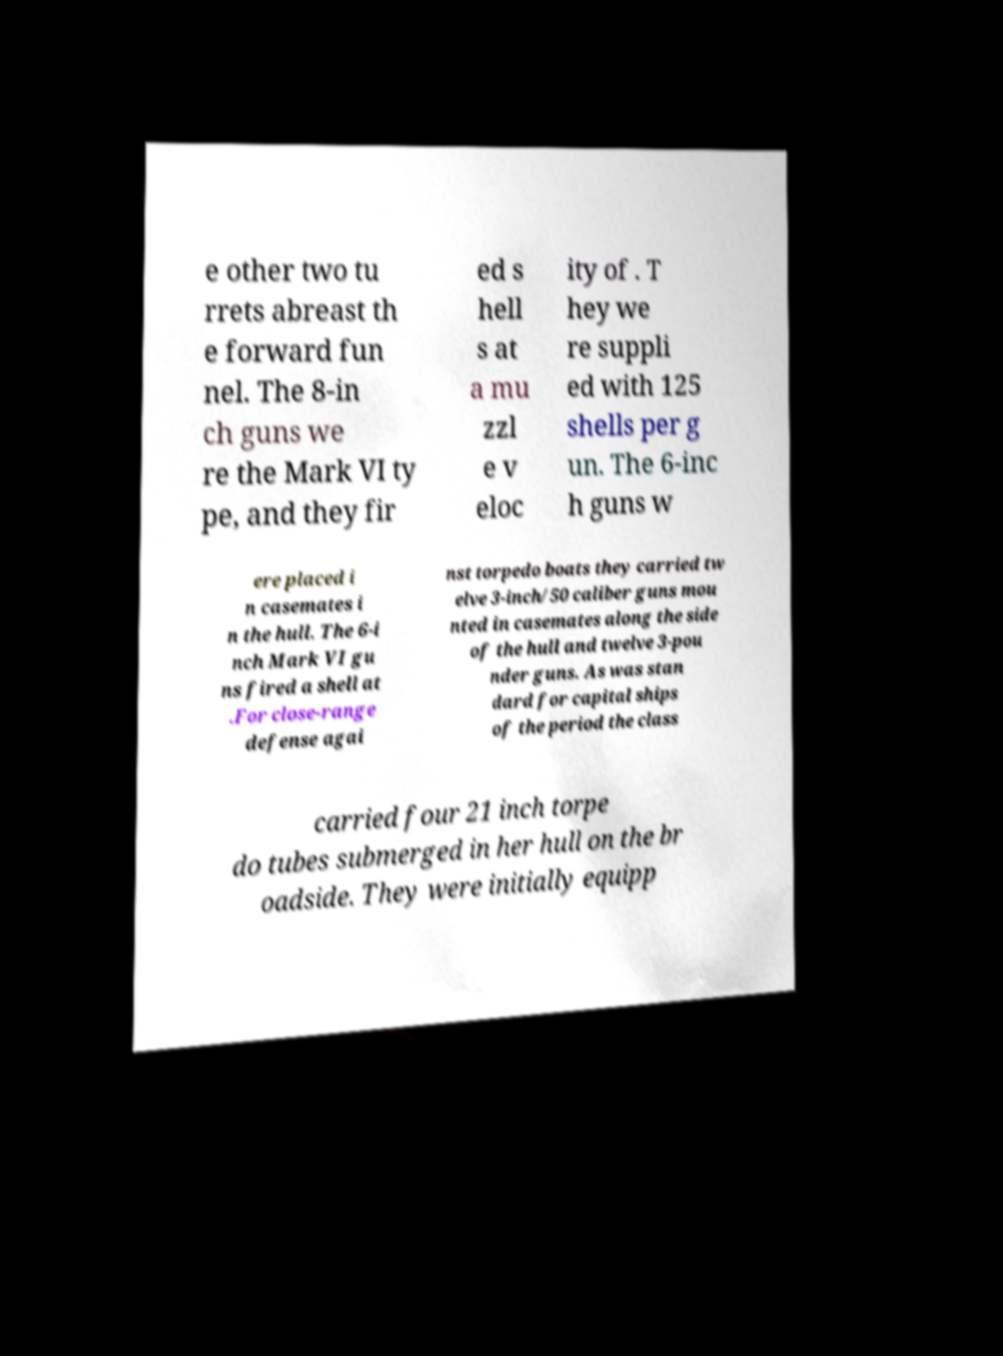Please read and relay the text visible in this image. What does it say? e other two tu rrets abreast th e forward fun nel. The 8-in ch guns we re the Mark VI ty pe, and they fir ed s hell s at a mu zzl e v eloc ity of . T hey we re suppli ed with 125 shells per g un. The 6-inc h guns w ere placed i n casemates i n the hull. The 6-i nch Mark VI gu ns fired a shell at .For close-range defense agai nst torpedo boats they carried tw elve 3-inch/50 caliber guns mou nted in casemates along the side of the hull and twelve 3-pou nder guns. As was stan dard for capital ships of the period the class carried four 21 inch torpe do tubes submerged in her hull on the br oadside. They were initially equipp 